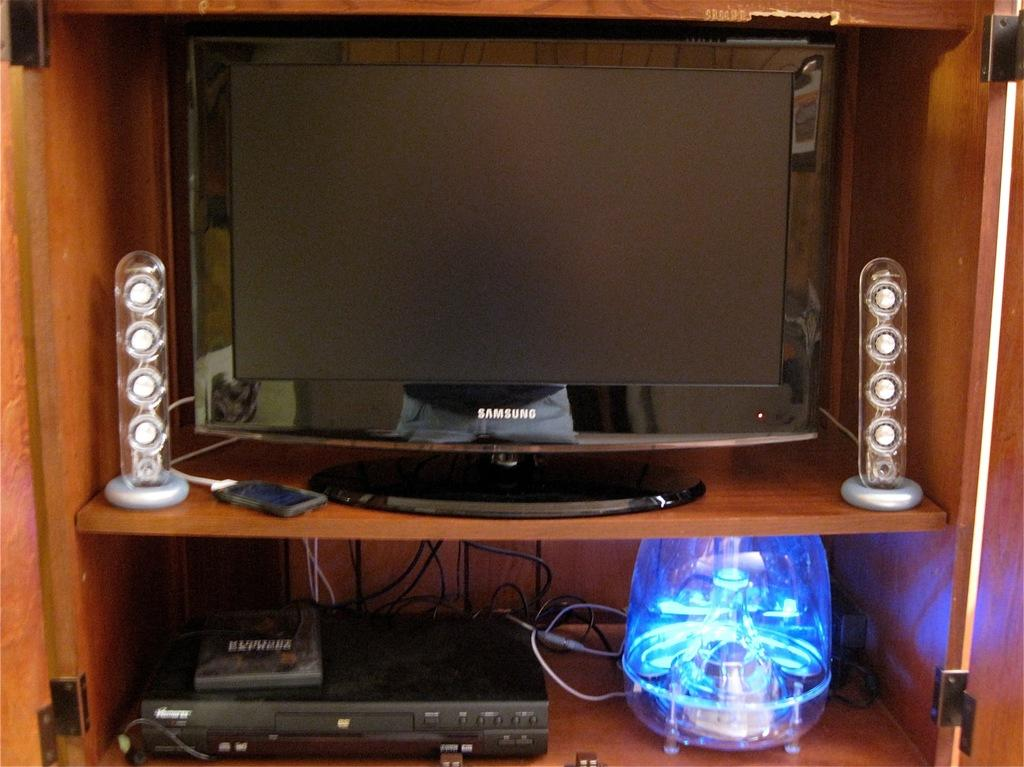<image>
Share a concise interpretation of the image provided. a Samsung television that has a lamp under it 